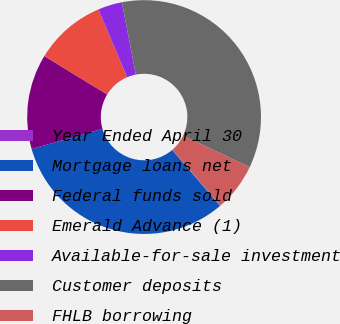<chart> <loc_0><loc_0><loc_500><loc_500><pie_chart><fcel>Year Ended April 30<fcel>Mortgage loans net<fcel>Federal funds sold<fcel>Emerald Advance (1)<fcel>Available-for-sale investment<fcel>Customer deposits<fcel>FHLB borrowing<nl><fcel>0.08%<fcel>31.84%<fcel>13.14%<fcel>9.88%<fcel>3.34%<fcel>35.11%<fcel>6.61%<nl></chart> 